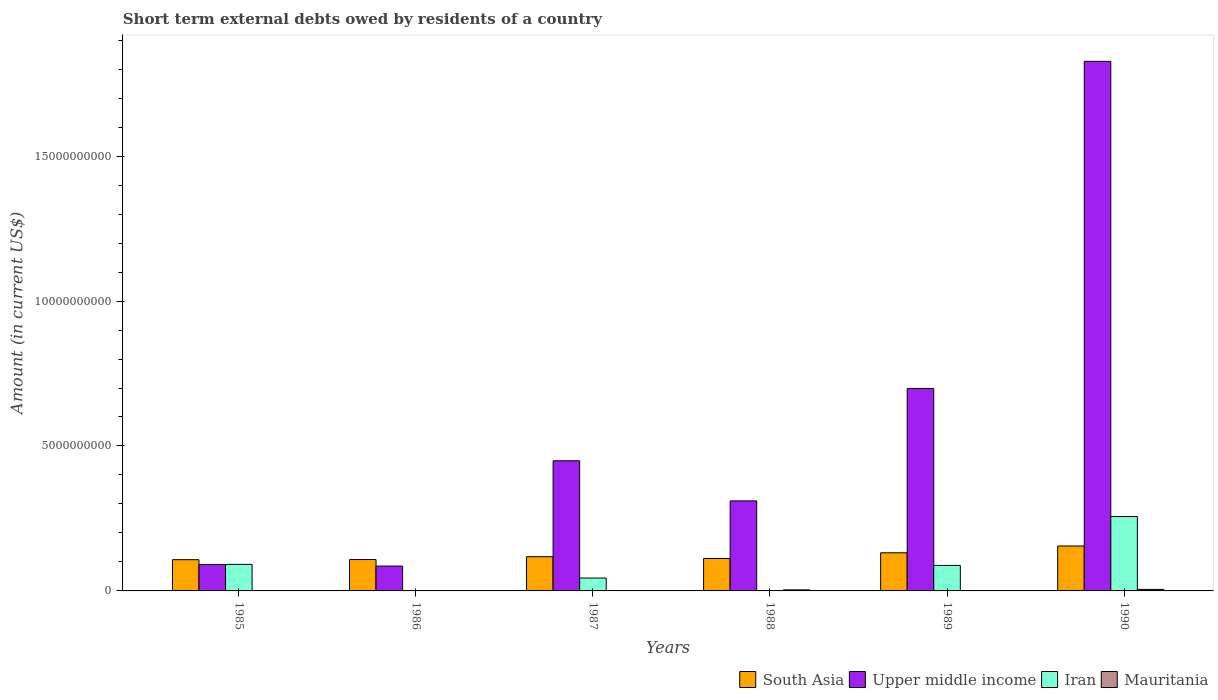How many different coloured bars are there?
Make the answer very short. 4. Are the number of bars per tick equal to the number of legend labels?
Provide a short and direct response. No. In how many cases, is the number of bars for a given year not equal to the number of legend labels?
Offer a terse response. 3. What is the amount of short-term external debts owed by residents in South Asia in 1986?
Give a very brief answer. 1.08e+09. Across all years, what is the maximum amount of short-term external debts owed by residents in Upper middle income?
Provide a succinct answer. 1.83e+1. Across all years, what is the minimum amount of short-term external debts owed by residents in Upper middle income?
Offer a terse response. 8.57e+08. What is the total amount of short-term external debts owed by residents in Mauritania in the graph?
Give a very brief answer. 9.72e+07. What is the difference between the amount of short-term external debts owed by residents in Mauritania in 1986 and that in 1990?
Your response must be concise. -4.88e+07. What is the difference between the amount of short-term external debts owed by residents in South Asia in 1986 and the amount of short-term external debts owed by residents in Iran in 1989?
Your answer should be very brief. 2.03e+08. What is the average amount of short-term external debts owed by residents in South Asia per year?
Provide a succinct answer. 1.22e+09. In the year 1990, what is the difference between the amount of short-term external debts owed by residents in South Asia and amount of short-term external debts owed by residents in Iran?
Your answer should be very brief. -1.02e+09. What is the ratio of the amount of short-term external debts owed by residents in South Asia in 1986 to that in 1987?
Ensure brevity in your answer.  0.92. Is the amount of short-term external debts owed by residents in South Asia in 1987 less than that in 1990?
Give a very brief answer. Yes. Is the difference between the amount of short-term external debts owed by residents in South Asia in 1985 and 1989 greater than the difference between the amount of short-term external debts owed by residents in Iran in 1985 and 1989?
Your answer should be very brief. No. What is the difference between the highest and the second highest amount of short-term external debts owed by residents in Mauritania?
Give a very brief answer. 1.54e+07. What is the difference between the highest and the lowest amount of short-term external debts owed by residents in Upper middle income?
Make the answer very short. 1.74e+1. Is the sum of the amount of short-term external debts owed by residents in South Asia in 1986 and 1990 greater than the maximum amount of short-term external debts owed by residents in Upper middle income across all years?
Give a very brief answer. No. Is it the case that in every year, the sum of the amount of short-term external debts owed by residents in Upper middle income and amount of short-term external debts owed by residents in South Asia is greater than the sum of amount of short-term external debts owed by residents in Mauritania and amount of short-term external debts owed by residents in Iran?
Make the answer very short. Yes. Is it the case that in every year, the sum of the amount of short-term external debts owed by residents in Upper middle income and amount of short-term external debts owed by residents in Mauritania is greater than the amount of short-term external debts owed by residents in Iran?
Give a very brief answer. No. What is the difference between two consecutive major ticks on the Y-axis?
Provide a succinct answer. 5.00e+09. Are the values on the major ticks of Y-axis written in scientific E-notation?
Your answer should be very brief. No. Does the graph contain grids?
Provide a short and direct response. No. Where does the legend appear in the graph?
Offer a very short reply. Bottom right. What is the title of the graph?
Provide a short and direct response. Short term external debts owed by residents of a country. What is the label or title of the X-axis?
Your answer should be very brief. Years. What is the Amount (in current US$) in South Asia in 1985?
Your response must be concise. 1.08e+09. What is the Amount (in current US$) of Upper middle income in 1985?
Make the answer very short. 9.09e+08. What is the Amount (in current US$) of Iran in 1985?
Give a very brief answer. 9.16e+08. What is the Amount (in current US$) of South Asia in 1986?
Your response must be concise. 1.08e+09. What is the Amount (in current US$) of Upper middle income in 1986?
Offer a very short reply. 8.57e+08. What is the Amount (in current US$) in Mauritania in 1986?
Keep it short and to the point. 3.78e+06. What is the Amount (in current US$) of South Asia in 1987?
Offer a terse response. 1.18e+09. What is the Amount (in current US$) of Upper middle income in 1987?
Offer a very short reply. 4.49e+09. What is the Amount (in current US$) of Iran in 1987?
Give a very brief answer. 4.44e+08. What is the Amount (in current US$) in Mauritania in 1987?
Your response must be concise. 2.72e+06. What is the Amount (in current US$) of South Asia in 1988?
Keep it short and to the point. 1.12e+09. What is the Amount (in current US$) in Upper middle income in 1988?
Make the answer very short. 3.11e+09. What is the Amount (in current US$) in Iran in 1988?
Keep it short and to the point. 0. What is the Amount (in current US$) in Mauritania in 1988?
Offer a terse response. 3.71e+07. What is the Amount (in current US$) in South Asia in 1989?
Offer a terse response. 1.32e+09. What is the Amount (in current US$) of Upper middle income in 1989?
Your response must be concise. 6.99e+09. What is the Amount (in current US$) in Iran in 1989?
Offer a very short reply. 8.80e+08. What is the Amount (in current US$) in Mauritania in 1989?
Your response must be concise. 0. What is the Amount (in current US$) of South Asia in 1990?
Offer a terse response. 1.55e+09. What is the Amount (in current US$) of Upper middle income in 1990?
Your response must be concise. 1.83e+1. What is the Amount (in current US$) of Iran in 1990?
Keep it short and to the point. 2.57e+09. What is the Amount (in current US$) of Mauritania in 1990?
Your answer should be compact. 5.25e+07. Across all years, what is the maximum Amount (in current US$) in South Asia?
Your response must be concise. 1.55e+09. Across all years, what is the maximum Amount (in current US$) of Upper middle income?
Offer a very short reply. 1.83e+1. Across all years, what is the maximum Amount (in current US$) of Iran?
Offer a terse response. 2.57e+09. Across all years, what is the maximum Amount (in current US$) in Mauritania?
Your answer should be compact. 5.25e+07. Across all years, what is the minimum Amount (in current US$) of South Asia?
Provide a short and direct response. 1.08e+09. Across all years, what is the minimum Amount (in current US$) in Upper middle income?
Offer a terse response. 8.57e+08. Across all years, what is the minimum Amount (in current US$) of Iran?
Offer a terse response. 0. What is the total Amount (in current US$) of South Asia in the graph?
Ensure brevity in your answer.  7.33e+09. What is the total Amount (in current US$) in Upper middle income in the graph?
Offer a terse response. 3.46e+1. What is the total Amount (in current US$) in Iran in the graph?
Your answer should be compact. 4.81e+09. What is the total Amount (in current US$) in Mauritania in the graph?
Offer a terse response. 9.72e+07. What is the difference between the Amount (in current US$) of South Asia in 1985 and that in 1986?
Keep it short and to the point. -5.31e+06. What is the difference between the Amount (in current US$) in Upper middle income in 1985 and that in 1986?
Provide a succinct answer. 5.16e+07. What is the difference between the Amount (in current US$) of Mauritania in 1985 and that in 1986?
Give a very brief answer. -2.78e+06. What is the difference between the Amount (in current US$) in South Asia in 1985 and that in 1987?
Give a very brief answer. -1.03e+08. What is the difference between the Amount (in current US$) in Upper middle income in 1985 and that in 1987?
Offer a very short reply. -3.58e+09. What is the difference between the Amount (in current US$) in Iran in 1985 and that in 1987?
Your answer should be compact. 4.71e+08. What is the difference between the Amount (in current US$) of Mauritania in 1985 and that in 1987?
Provide a short and direct response. -1.72e+06. What is the difference between the Amount (in current US$) of South Asia in 1985 and that in 1988?
Provide a short and direct response. -4.12e+07. What is the difference between the Amount (in current US$) of Upper middle income in 1985 and that in 1988?
Ensure brevity in your answer.  -2.20e+09. What is the difference between the Amount (in current US$) in Mauritania in 1985 and that in 1988?
Keep it short and to the point. -3.61e+07. What is the difference between the Amount (in current US$) in South Asia in 1985 and that in 1989?
Make the answer very short. -2.38e+08. What is the difference between the Amount (in current US$) in Upper middle income in 1985 and that in 1989?
Provide a succinct answer. -6.08e+09. What is the difference between the Amount (in current US$) of Iran in 1985 and that in 1989?
Ensure brevity in your answer.  3.60e+07. What is the difference between the Amount (in current US$) of South Asia in 1985 and that in 1990?
Make the answer very short. -4.72e+08. What is the difference between the Amount (in current US$) of Upper middle income in 1985 and that in 1990?
Your answer should be compact. -1.74e+1. What is the difference between the Amount (in current US$) of Iran in 1985 and that in 1990?
Offer a terse response. -1.65e+09. What is the difference between the Amount (in current US$) in Mauritania in 1985 and that in 1990?
Offer a terse response. -5.15e+07. What is the difference between the Amount (in current US$) of South Asia in 1986 and that in 1987?
Ensure brevity in your answer.  -9.80e+07. What is the difference between the Amount (in current US$) in Upper middle income in 1986 and that in 1987?
Keep it short and to the point. -3.63e+09. What is the difference between the Amount (in current US$) of Mauritania in 1986 and that in 1987?
Your response must be concise. 1.06e+06. What is the difference between the Amount (in current US$) in South Asia in 1986 and that in 1988?
Give a very brief answer. -3.59e+07. What is the difference between the Amount (in current US$) of Upper middle income in 1986 and that in 1988?
Offer a very short reply. -2.25e+09. What is the difference between the Amount (in current US$) in Mauritania in 1986 and that in 1988?
Your answer should be very brief. -3.33e+07. What is the difference between the Amount (in current US$) of South Asia in 1986 and that in 1989?
Ensure brevity in your answer.  -2.32e+08. What is the difference between the Amount (in current US$) in Upper middle income in 1986 and that in 1989?
Offer a terse response. -6.13e+09. What is the difference between the Amount (in current US$) of South Asia in 1986 and that in 1990?
Make the answer very short. -4.67e+08. What is the difference between the Amount (in current US$) in Upper middle income in 1986 and that in 1990?
Your answer should be very brief. -1.74e+1. What is the difference between the Amount (in current US$) in Mauritania in 1986 and that in 1990?
Your answer should be compact. -4.88e+07. What is the difference between the Amount (in current US$) in South Asia in 1987 and that in 1988?
Provide a succinct answer. 6.21e+07. What is the difference between the Amount (in current US$) in Upper middle income in 1987 and that in 1988?
Ensure brevity in your answer.  1.38e+09. What is the difference between the Amount (in current US$) in Mauritania in 1987 and that in 1988?
Ensure brevity in your answer.  -3.44e+07. What is the difference between the Amount (in current US$) in South Asia in 1987 and that in 1989?
Your response must be concise. -1.34e+08. What is the difference between the Amount (in current US$) of Upper middle income in 1987 and that in 1989?
Offer a very short reply. -2.50e+09. What is the difference between the Amount (in current US$) of Iran in 1987 and that in 1989?
Your answer should be very brief. -4.35e+08. What is the difference between the Amount (in current US$) in South Asia in 1987 and that in 1990?
Your answer should be very brief. -3.69e+08. What is the difference between the Amount (in current US$) in Upper middle income in 1987 and that in 1990?
Keep it short and to the point. -1.38e+1. What is the difference between the Amount (in current US$) of Iran in 1987 and that in 1990?
Your answer should be very brief. -2.12e+09. What is the difference between the Amount (in current US$) of Mauritania in 1987 and that in 1990?
Provide a short and direct response. -4.98e+07. What is the difference between the Amount (in current US$) in South Asia in 1988 and that in 1989?
Your answer should be compact. -1.97e+08. What is the difference between the Amount (in current US$) of Upper middle income in 1988 and that in 1989?
Keep it short and to the point. -3.88e+09. What is the difference between the Amount (in current US$) in South Asia in 1988 and that in 1990?
Ensure brevity in your answer.  -4.31e+08. What is the difference between the Amount (in current US$) of Upper middle income in 1988 and that in 1990?
Provide a succinct answer. -1.52e+1. What is the difference between the Amount (in current US$) of Mauritania in 1988 and that in 1990?
Offer a very short reply. -1.54e+07. What is the difference between the Amount (in current US$) in South Asia in 1989 and that in 1990?
Provide a short and direct response. -2.34e+08. What is the difference between the Amount (in current US$) in Upper middle income in 1989 and that in 1990?
Keep it short and to the point. -1.13e+1. What is the difference between the Amount (in current US$) of Iran in 1989 and that in 1990?
Provide a short and direct response. -1.69e+09. What is the difference between the Amount (in current US$) in South Asia in 1985 and the Amount (in current US$) in Upper middle income in 1986?
Provide a succinct answer. 2.20e+08. What is the difference between the Amount (in current US$) in South Asia in 1985 and the Amount (in current US$) in Mauritania in 1986?
Provide a succinct answer. 1.07e+09. What is the difference between the Amount (in current US$) in Upper middle income in 1985 and the Amount (in current US$) in Mauritania in 1986?
Make the answer very short. 9.05e+08. What is the difference between the Amount (in current US$) of Iran in 1985 and the Amount (in current US$) of Mauritania in 1986?
Offer a very short reply. 9.12e+08. What is the difference between the Amount (in current US$) of South Asia in 1985 and the Amount (in current US$) of Upper middle income in 1987?
Offer a terse response. -3.41e+09. What is the difference between the Amount (in current US$) in South Asia in 1985 and the Amount (in current US$) in Iran in 1987?
Ensure brevity in your answer.  6.33e+08. What is the difference between the Amount (in current US$) of South Asia in 1985 and the Amount (in current US$) of Mauritania in 1987?
Your answer should be very brief. 1.07e+09. What is the difference between the Amount (in current US$) in Upper middle income in 1985 and the Amount (in current US$) in Iran in 1987?
Provide a short and direct response. 4.64e+08. What is the difference between the Amount (in current US$) of Upper middle income in 1985 and the Amount (in current US$) of Mauritania in 1987?
Offer a terse response. 9.06e+08. What is the difference between the Amount (in current US$) of Iran in 1985 and the Amount (in current US$) of Mauritania in 1987?
Your answer should be compact. 9.13e+08. What is the difference between the Amount (in current US$) in South Asia in 1985 and the Amount (in current US$) in Upper middle income in 1988?
Your response must be concise. -2.03e+09. What is the difference between the Amount (in current US$) of South Asia in 1985 and the Amount (in current US$) of Mauritania in 1988?
Make the answer very short. 1.04e+09. What is the difference between the Amount (in current US$) of Upper middle income in 1985 and the Amount (in current US$) of Mauritania in 1988?
Make the answer very short. 8.72e+08. What is the difference between the Amount (in current US$) of Iran in 1985 and the Amount (in current US$) of Mauritania in 1988?
Offer a terse response. 8.79e+08. What is the difference between the Amount (in current US$) in South Asia in 1985 and the Amount (in current US$) in Upper middle income in 1989?
Keep it short and to the point. -5.91e+09. What is the difference between the Amount (in current US$) of South Asia in 1985 and the Amount (in current US$) of Iran in 1989?
Offer a terse response. 1.98e+08. What is the difference between the Amount (in current US$) in Upper middle income in 1985 and the Amount (in current US$) in Iran in 1989?
Provide a succinct answer. 2.91e+07. What is the difference between the Amount (in current US$) in South Asia in 1985 and the Amount (in current US$) in Upper middle income in 1990?
Give a very brief answer. -1.72e+1. What is the difference between the Amount (in current US$) of South Asia in 1985 and the Amount (in current US$) of Iran in 1990?
Provide a short and direct response. -1.49e+09. What is the difference between the Amount (in current US$) in South Asia in 1985 and the Amount (in current US$) in Mauritania in 1990?
Keep it short and to the point. 1.02e+09. What is the difference between the Amount (in current US$) in Upper middle income in 1985 and the Amount (in current US$) in Iran in 1990?
Keep it short and to the point. -1.66e+09. What is the difference between the Amount (in current US$) of Upper middle income in 1985 and the Amount (in current US$) of Mauritania in 1990?
Offer a terse response. 8.56e+08. What is the difference between the Amount (in current US$) of Iran in 1985 and the Amount (in current US$) of Mauritania in 1990?
Offer a terse response. 8.63e+08. What is the difference between the Amount (in current US$) in South Asia in 1986 and the Amount (in current US$) in Upper middle income in 1987?
Offer a terse response. -3.41e+09. What is the difference between the Amount (in current US$) in South Asia in 1986 and the Amount (in current US$) in Iran in 1987?
Keep it short and to the point. 6.38e+08. What is the difference between the Amount (in current US$) in South Asia in 1986 and the Amount (in current US$) in Mauritania in 1987?
Make the answer very short. 1.08e+09. What is the difference between the Amount (in current US$) of Upper middle income in 1986 and the Amount (in current US$) of Iran in 1987?
Offer a very short reply. 4.13e+08. What is the difference between the Amount (in current US$) of Upper middle income in 1986 and the Amount (in current US$) of Mauritania in 1987?
Give a very brief answer. 8.55e+08. What is the difference between the Amount (in current US$) in South Asia in 1986 and the Amount (in current US$) in Upper middle income in 1988?
Your response must be concise. -2.02e+09. What is the difference between the Amount (in current US$) in South Asia in 1986 and the Amount (in current US$) in Mauritania in 1988?
Ensure brevity in your answer.  1.05e+09. What is the difference between the Amount (in current US$) in Upper middle income in 1986 and the Amount (in current US$) in Mauritania in 1988?
Offer a very short reply. 8.20e+08. What is the difference between the Amount (in current US$) of South Asia in 1986 and the Amount (in current US$) of Upper middle income in 1989?
Make the answer very short. -5.90e+09. What is the difference between the Amount (in current US$) in South Asia in 1986 and the Amount (in current US$) in Iran in 1989?
Ensure brevity in your answer.  2.03e+08. What is the difference between the Amount (in current US$) in Upper middle income in 1986 and the Amount (in current US$) in Iran in 1989?
Offer a terse response. -2.25e+07. What is the difference between the Amount (in current US$) in South Asia in 1986 and the Amount (in current US$) in Upper middle income in 1990?
Keep it short and to the point. -1.72e+1. What is the difference between the Amount (in current US$) of South Asia in 1986 and the Amount (in current US$) of Iran in 1990?
Your answer should be compact. -1.48e+09. What is the difference between the Amount (in current US$) of South Asia in 1986 and the Amount (in current US$) of Mauritania in 1990?
Your answer should be compact. 1.03e+09. What is the difference between the Amount (in current US$) in Upper middle income in 1986 and the Amount (in current US$) in Iran in 1990?
Provide a succinct answer. -1.71e+09. What is the difference between the Amount (in current US$) in Upper middle income in 1986 and the Amount (in current US$) in Mauritania in 1990?
Your answer should be compact. 8.05e+08. What is the difference between the Amount (in current US$) in South Asia in 1987 and the Amount (in current US$) in Upper middle income in 1988?
Provide a succinct answer. -1.92e+09. What is the difference between the Amount (in current US$) in South Asia in 1987 and the Amount (in current US$) in Mauritania in 1988?
Your answer should be very brief. 1.14e+09. What is the difference between the Amount (in current US$) of Upper middle income in 1987 and the Amount (in current US$) of Mauritania in 1988?
Keep it short and to the point. 4.45e+09. What is the difference between the Amount (in current US$) of Iran in 1987 and the Amount (in current US$) of Mauritania in 1988?
Your answer should be compact. 4.07e+08. What is the difference between the Amount (in current US$) in South Asia in 1987 and the Amount (in current US$) in Upper middle income in 1989?
Offer a terse response. -5.80e+09. What is the difference between the Amount (in current US$) of South Asia in 1987 and the Amount (in current US$) of Iran in 1989?
Give a very brief answer. 3.01e+08. What is the difference between the Amount (in current US$) of Upper middle income in 1987 and the Amount (in current US$) of Iran in 1989?
Make the answer very short. 3.61e+09. What is the difference between the Amount (in current US$) of South Asia in 1987 and the Amount (in current US$) of Upper middle income in 1990?
Provide a short and direct response. -1.71e+1. What is the difference between the Amount (in current US$) of South Asia in 1987 and the Amount (in current US$) of Iran in 1990?
Make the answer very short. -1.39e+09. What is the difference between the Amount (in current US$) of South Asia in 1987 and the Amount (in current US$) of Mauritania in 1990?
Give a very brief answer. 1.13e+09. What is the difference between the Amount (in current US$) of Upper middle income in 1987 and the Amount (in current US$) of Iran in 1990?
Your answer should be very brief. 1.92e+09. What is the difference between the Amount (in current US$) in Upper middle income in 1987 and the Amount (in current US$) in Mauritania in 1990?
Your answer should be very brief. 4.44e+09. What is the difference between the Amount (in current US$) of Iran in 1987 and the Amount (in current US$) of Mauritania in 1990?
Provide a succinct answer. 3.92e+08. What is the difference between the Amount (in current US$) of South Asia in 1988 and the Amount (in current US$) of Upper middle income in 1989?
Provide a short and direct response. -5.87e+09. What is the difference between the Amount (in current US$) of South Asia in 1988 and the Amount (in current US$) of Iran in 1989?
Offer a terse response. 2.39e+08. What is the difference between the Amount (in current US$) of Upper middle income in 1988 and the Amount (in current US$) of Iran in 1989?
Your answer should be very brief. 2.23e+09. What is the difference between the Amount (in current US$) in South Asia in 1988 and the Amount (in current US$) in Upper middle income in 1990?
Ensure brevity in your answer.  -1.71e+1. What is the difference between the Amount (in current US$) in South Asia in 1988 and the Amount (in current US$) in Iran in 1990?
Make the answer very short. -1.45e+09. What is the difference between the Amount (in current US$) of South Asia in 1988 and the Amount (in current US$) of Mauritania in 1990?
Offer a terse response. 1.07e+09. What is the difference between the Amount (in current US$) in Upper middle income in 1988 and the Amount (in current US$) in Iran in 1990?
Offer a terse response. 5.40e+08. What is the difference between the Amount (in current US$) in Upper middle income in 1988 and the Amount (in current US$) in Mauritania in 1990?
Offer a terse response. 3.05e+09. What is the difference between the Amount (in current US$) of South Asia in 1989 and the Amount (in current US$) of Upper middle income in 1990?
Offer a terse response. -1.70e+1. What is the difference between the Amount (in current US$) of South Asia in 1989 and the Amount (in current US$) of Iran in 1990?
Offer a terse response. -1.25e+09. What is the difference between the Amount (in current US$) of South Asia in 1989 and the Amount (in current US$) of Mauritania in 1990?
Your answer should be very brief. 1.26e+09. What is the difference between the Amount (in current US$) of Upper middle income in 1989 and the Amount (in current US$) of Iran in 1990?
Give a very brief answer. 4.42e+09. What is the difference between the Amount (in current US$) in Upper middle income in 1989 and the Amount (in current US$) in Mauritania in 1990?
Your answer should be very brief. 6.93e+09. What is the difference between the Amount (in current US$) in Iran in 1989 and the Amount (in current US$) in Mauritania in 1990?
Give a very brief answer. 8.27e+08. What is the average Amount (in current US$) of South Asia per year?
Ensure brevity in your answer.  1.22e+09. What is the average Amount (in current US$) of Upper middle income per year?
Give a very brief answer. 5.77e+09. What is the average Amount (in current US$) of Iran per year?
Give a very brief answer. 8.01e+08. What is the average Amount (in current US$) of Mauritania per year?
Provide a succinct answer. 1.62e+07. In the year 1985, what is the difference between the Amount (in current US$) in South Asia and Amount (in current US$) in Upper middle income?
Ensure brevity in your answer.  1.69e+08. In the year 1985, what is the difference between the Amount (in current US$) in South Asia and Amount (in current US$) in Iran?
Ensure brevity in your answer.  1.62e+08. In the year 1985, what is the difference between the Amount (in current US$) in South Asia and Amount (in current US$) in Mauritania?
Provide a succinct answer. 1.08e+09. In the year 1985, what is the difference between the Amount (in current US$) in Upper middle income and Amount (in current US$) in Iran?
Give a very brief answer. -6.94e+06. In the year 1985, what is the difference between the Amount (in current US$) in Upper middle income and Amount (in current US$) in Mauritania?
Your response must be concise. 9.08e+08. In the year 1985, what is the difference between the Amount (in current US$) of Iran and Amount (in current US$) of Mauritania?
Keep it short and to the point. 9.15e+08. In the year 1986, what is the difference between the Amount (in current US$) in South Asia and Amount (in current US$) in Upper middle income?
Your answer should be very brief. 2.26e+08. In the year 1986, what is the difference between the Amount (in current US$) of South Asia and Amount (in current US$) of Mauritania?
Provide a succinct answer. 1.08e+09. In the year 1986, what is the difference between the Amount (in current US$) of Upper middle income and Amount (in current US$) of Mauritania?
Offer a very short reply. 8.54e+08. In the year 1987, what is the difference between the Amount (in current US$) in South Asia and Amount (in current US$) in Upper middle income?
Provide a short and direct response. -3.31e+09. In the year 1987, what is the difference between the Amount (in current US$) of South Asia and Amount (in current US$) of Iran?
Your answer should be compact. 7.36e+08. In the year 1987, what is the difference between the Amount (in current US$) of South Asia and Amount (in current US$) of Mauritania?
Your answer should be very brief. 1.18e+09. In the year 1987, what is the difference between the Amount (in current US$) in Upper middle income and Amount (in current US$) in Iran?
Give a very brief answer. 4.04e+09. In the year 1987, what is the difference between the Amount (in current US$) of Upper middle income and Amount (in current US$) of Mauritania?
Offer a terse response. 4.49e+09. In the year 1987, what is the difference between the Amount (in current US$) of Iran and Amount (in current US$) of Mauritania?
Provide a succinct answer. 4.42e+08. In the year 1988, what is the difference between the Amount (in current US$) of South Asia and Amount (in current US$) of Upper middle income?
Your answer should be very brief. -1.99e+09. In the year 1988, what is the difference between the Amount (in current US$) in South Asia and Amount (in current US$) in Mauritania?
Offer a very short reply. 1.08e+09. In the year 1988, what is the difference between the Amount (in current US$) of Upper middle income and Amount (in current US$) of Mauritania?
Make the answer very short. 3.07e+09. In the year 1989, what is the difference between the Amount (in current US$) of South Asia and Amount (in current US$) of Upper middle income?
Offer a terse response. -5.67e+09. In the year 1989, what is the difference between the Amount (in current US$) of South Asia and Amount (in current US$) of Iran?
Ensure brevity in your answer.  4.36e+08. In the year 1989, what is the difference between the Amount (in current US$) in Upper middle income and Amount (in current US$) in Iran?
Your answer should be compact. 6.11e+09. In the year 1990, what is the difference between the Amount (in current US$) of South Asia and Amount (in current US$) of Upper middle income?
Make the answer very short. -1.67e+1. In the year 1990, what is the difference between the Amount (in current US$) in South Asia and Amount (in current US$) in Iran?
Give a very brief answer. -1.02e+09. In the year 1990, what is the difference between the Amount (in current US$) in South Asia and Amount (in current US$) in Mauritania?
Provide a short and direct response. 1.50e+09. In the year 1990, what is the difference between the Amount (in current US$) in Upper middle income and Amount (in current US$) in Iran?
Offer a very short reply. 1.57e+1. In the year 1990, what is the difference between the Amount (in current US$) of Upper middle income and Amount (in current US$) of Mauritania?
Give a very brief answer. 1.82e+1. In the year 1990, what is the difference between the Amount (in current US$) of Iran and Amount (in current US$) of Mauritania?
Offer a terse response. 2.51e+09. What is the ratio of the Amount (in current US$) of Upper middle income in 1985 to that in 1986?
Offer a terse response. 1.06. What is the ratio of the Amount (in current US$) of Mauritania in 1985 to that in 1986?
Your response must be concise. 0.26. What is the ratio of the Amount (in current US$) of South Asia in 1985 to that in 1987?
Your answer should be very brief. 0.91. What is the ratio of the Amount (in current US$) of Upper middle income in 1985 to that in 1987?
Offer a terse response. 0.2. What is the ratio of the Amount (in current US$) of Iran in 1985 to that in 1987?
Provide a short and direct response. 2.06. What is the ratio of the Amount (in current US$) in Mauritania in 1985 to that in 1987?
Give a very brief answer. 0.37. What is the ratio of the Amount (in current US$) of South Asia in 1985 to that in 1988?
Provide a short and direct response. 0.96. What is the ratio of the Amount (in current US$) in Upper middle income in 1985 to that in 1988?
Provide a succinct answer. 0.29. What is the ratio of the Amount (in current US$) in Mauritania in 1985 to that in 1988?
Provide a succinct answer. 0.03. What is the ratio of the Amount (in current US$) in South Asia in 1985 to that in 1989?
Provide a succinct answer. 0.82. What is the ratio of the Amount (in current US$) in Upper middle income in 1985 to that in 1989?
Your response must be concise. 0.13. What is the ratio of the Amount (in current US$) in Iran in 1985 to that in 1989?
Offer a terse response. 1.04. What is the ratio of the Amount (in current US$) of South Asia in 1985 to that in 1990?
Give a very brief answer. 0.7. What is the ratio of the Amount (in current US$) in Upper middle income in 1985 to that in 1990?
Provide a short and direct response. 0.05. What is the ratio of the Amount (in current US$) in Iran in 1985 to that in 1990?
Offer a terse response. 0.36. What is the ratio of the Amount (in current US$) of Mauritania in 1985 to that in 1990?
Offer a terse response. 0.02. What is the ratio of the Amount (in current US$) in South Asia in 1986 to that in 1987?
Provide a short and direct response. 0.92. What is the ratio of the Amount (in current US$) in Upper middle income in 1986 to that in 1987?
Your answer should be compact. 0.19. What is the ratio of the Amount (in current US$) of Mauritania in 1986 to that in 1987?
Ensure brevity in your answer.  1.39. What is the ratio of the Amount (in current US$) in South Asia in 1986 to that in 1988?
Your response must be concise. 0.97. What is the ratio of the Amount (in current US$) of Upper middle income in 1986 to that in 1988?
Your answer should be compact. 0.28. What is the ratio of the Amount (in current US$) in Mauritania in 1986 to that in 1988?
Ensure brevity in your answer.  0.1. What is the ratio of the Amount (in current US$) in South Asia in 1986 to that in 1989?
Keep it short and to the point. 0.82. What is the ratio of the Amount (in current US$) of Upper middle income in 1986 to that in 1989?
Ensure brevity in your answer.  0.12. What is the ratio of the Amount (in current US$) of South Asia in 1986 to that in 1990?
Your answer should be very brief. 0.7. What is the ratio of the Amount (in current US$) of Upper middle income in 1986 to that in 1990?
Offer a terse response. 0.05. What is the ratio of the Amount (in current US$) in Mauritania in 1986 to that in 1990?
Your response must be concise. 0.07. What is the ratio of the Amount (in current US$) in South Asia in 1987 to that in 1988?
Offer a terse response. 1.06. What is the ratio of the Amount (in current US$) in Upper middle income in 1987 to that in 1988?
Offer a terse response. 1.45. What is the ratio of the Amount (in current US$) in Mauritania in 1987 to that in 1988?
Offer a terse response. 0.07. What is the ratio of the Amount (in current US$) of South Asia in 1987 to that in 1989?
Give a very brief answer. 0.9. What is the ratio of the Amount (in current US$) in Upper middle income in 1987 to that in 1989?
Give a very brief answer. 0.64. What is the ratio of the Amount (in current US$) of Iran in 1987 to that in 1989?
Your answer should be very brief. 0.51. What is the ratio of the Amount (in current US$) in South Asia in 1987 to that in 1990?
Provide a succinct answer. 0.76. What is the ratio of the Amount (in current US$) of Upper middle income in 1987 to that in 1990?
Provide a succinct answer. 0.25. What is the ratio of the Amount (in current US$) in Iran in 1987 to that in 1990?
Your answer should be compact. 0.17. What is the ratio of the Amount (in current US$) in Mauritania in 1987 to that in 1990?
Your response must be concise. 0.05. What is the ratio of the Amount (in current US$) of South Asia in 1988 to that in 1989?
Provide a short and direct response. 0.85. What is the ratio of the Amount (in current US$) in Upper middle income in 1988 to that in 1989?
Make the answer very short. 0.44. What is the ratio of the Amount (in current US$) in South Asia in 1988 to that in 1990?
Offer a terse response. 0.72. What is the ratio of the Amount (in current US$) of Upper middle income in 1988 to that in 1990?
Your answer should be compact. 0.17. What is the ratio of the Amount (in current US$) of Mauritania in 1988 to that in 1990?
Provide a short and direct response. 0.71. What is the ratio of the Amount (in current US$) in South Asia in 1989 to that in 1990?
Offer a terse response. 0.85. What is the ratio of the Amount (in current US$) in Upper middle income in 1989 to that in 1990?
Offer a terse response. 0.38. What is the ratio of the Amount (in current US$) of Iran in 1989 to that in 1990?
Ensure brevity in your answer.  0.34. What is the difference between the highest and the second highest Amount (in current US$) of South Asia?
Give a very brief answer. 2.34e+08. What is the difference between the highest and the second highest Amount (in current US$) of Upper middle income?
Ensure brevity in your answer.  1.13e+1. What is the difference between the highest and the second highest Amount (in current US$) in Iran?
Ensure brevity in your answer.  1.65e+09. What is the difference between the highest and the second highest Amount (in current US$) in Mauritania?
Your answer should be compact. 1.54e+07. What is the difference between the highest and the lowest Amount (in current US$) of South Asia?
Your answer should be compact. 4.72e+08. What is the difference between the highest and the lowest Amount (in current US$) of Upper middle income?
Your answer should be compact. 1.74e+1. What is the difference between the highest and the lowest Amount (in current US$) of Iran?
Keep it short and to the point. 2.57e+09. What is the difference between the highest and the lowest Amount (in current US$) of Mauritania?
Give a very brief answer. 5.25e+07. 